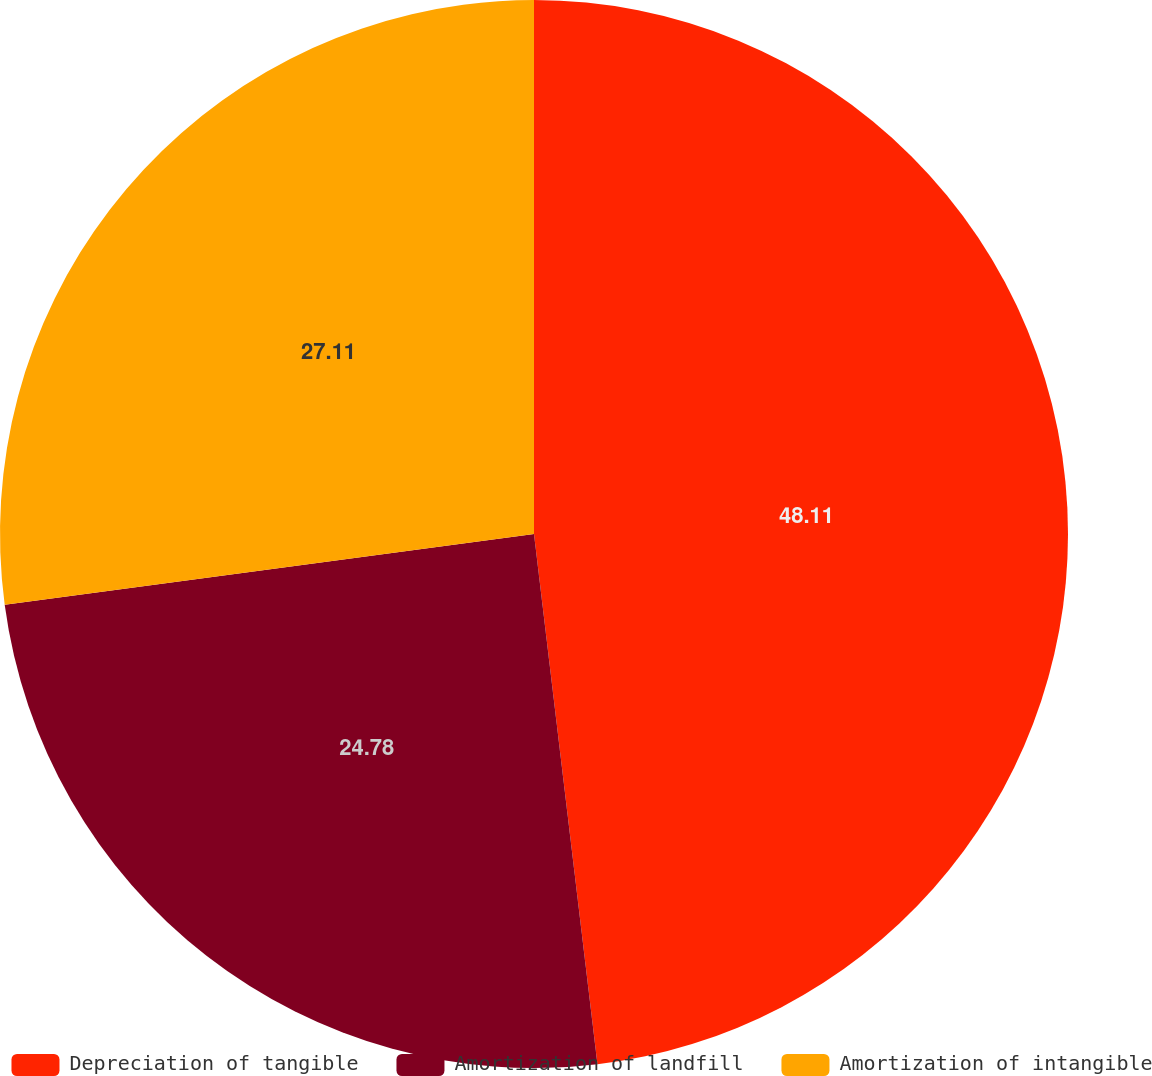Convert chart to OTSL. <chart><loc_0><loc_0><loc_500><loc_500><pie_chart><fcel>Depreciation of tangible<fcel>Amortization of landfill<fcel>Amortization of intangible<nl><fcel>48.1%<fcel>24.78%<fcel>27.11%<nl></chart> 